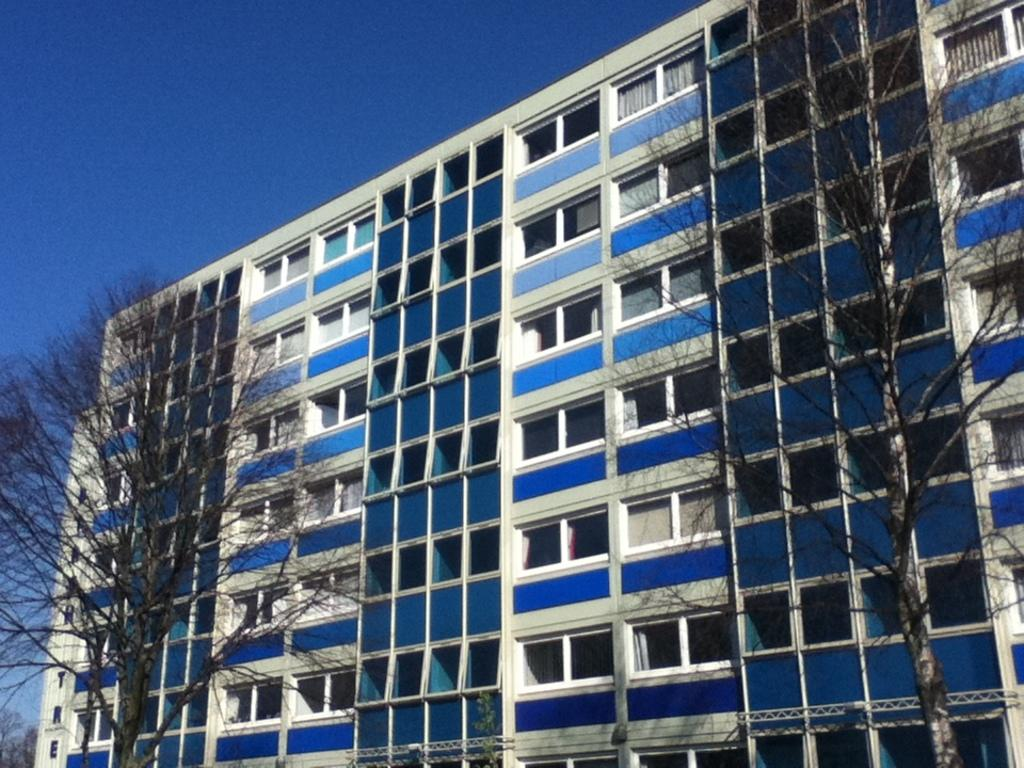What structure is the main subject of the image? There is a building in the image. What can be seen in front of the building? There are two trees in front of the building. What part of the sky is visible in the image? The sky is visible on the left side of the image. What type of jewel can be seen on the table in the image? There is no table or jewel present in the image; it only features a building and two trees. 